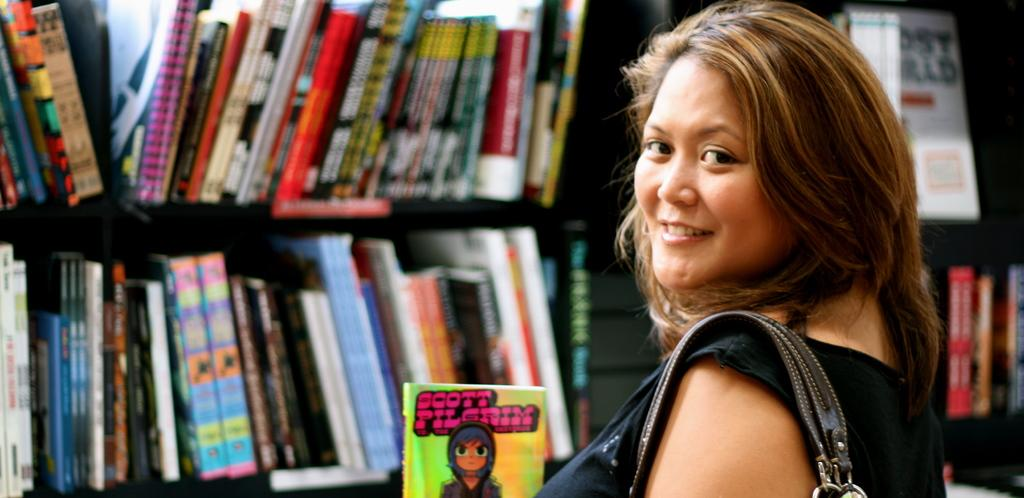<image>
Present a compact description of the photo's key features. The lady at the library holds a Scott Pilgrim book. 